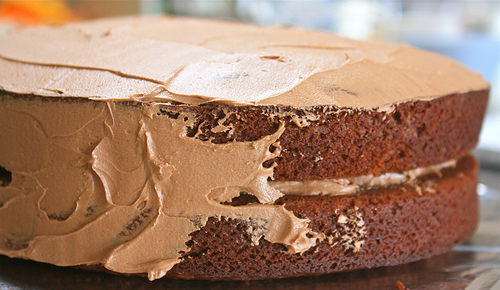<image>
Can you confirm if the chocolate cake is behind the chocolate frosting? No. The chocolate cake is not behind the chocolate frosting. From this viewpoint, the chocolate cake appears to be positioned elsewhere in the scene. 